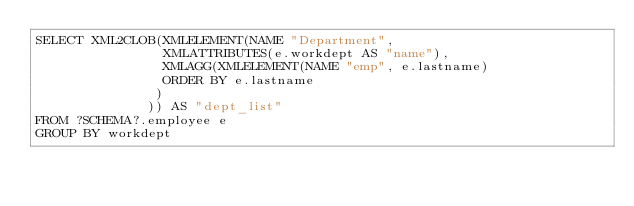Convert code to text. <code><loc_0><loc_0><loc_500><loc_500><_SQL_>SELECT XML2CLOB(XMLELEMENT(NAME "Department",
                XMLATTRIBUTES(e.workdept AS "name"),
                XMLAGG(XMLELEMENT(NAME "emp", e.lastname)
                ORDER BY e.lastname
               )
              )) AS "dept_list"
FROM ?SCHEMA?.employee e
GROUP BY workdept
</code> 